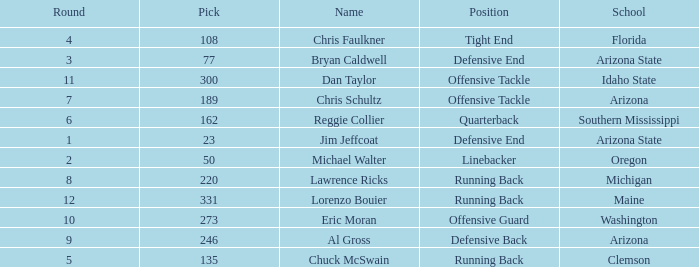What is the number of the pick for round 11? 300.0. 